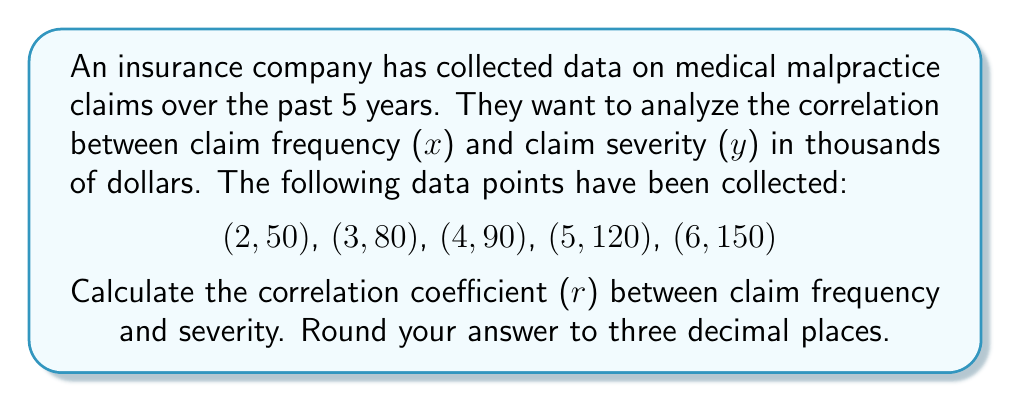Can you answer this question? To calculate the correlation coefficient (r), we'll use the formula:

$$ r = \frac{n\sum xy - \sum x \sum y}{\sqrt{[n\sum x^2 - (\sum x)^2][n\sum y^2 - (\sum y)^2]}} $$

Where n is the number of data points.

Step 1: Calculate the sums and squares:
n = 5
$\sum x = 2 + 3 + 4 + 5 + 6 = 20$
$\sum y = 50 + 80 + 90 + 120 + 150 = 490$
$\sum xy = (2)(50) + (3)(80) + (4)(90) + (5)(120) + (6)(150) = 2170$
$\sum x^2 = 2^2 + 3^2 + 4^2 + 5^2 + 6^2 = 90$
$\sum y^2 = 50^2 + 80^2 + 90^2 + 120^2 + 150^2 = 69700$

Step 2: Apply the formula:

$$ r = \frac{5(2170) - (20)(490)}{\sqrt{[5(90) - (20)^2][5(69700) - (490)^2]}} $$

Step 3: Simplify:

$$ r = \frac{10850 - 9800}{\sqrt{(450 - 400)(348500 - 240100)}} $$

$$ r = \frac{1050}{\sqrt{(50)(108400)}} $$

$$ r = \frac{1050}{\sqrt{5420000}} $$

$$ r = \frac{1050}{2328.09} $$

$$ r \approx 0.451 $$

Therefore, the correlation coefficient between claim frequency and severity is approximately 0.451.
Answer: 0.451 